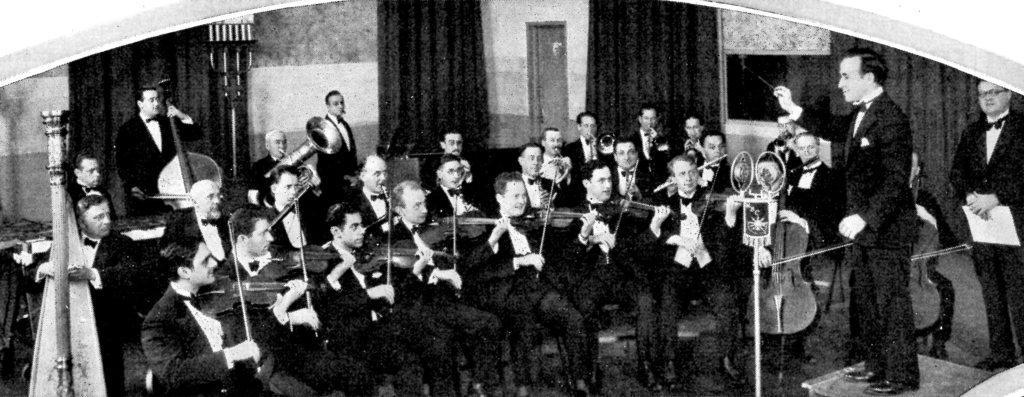Could you give a brief overview of what you see in this image? In the picture we can see a group of people sitting on the chairs and playing the musical instruments and they are in blazers, ties and shirts and in front of them we can see a man giving training to them and behind them we can see few people are standing with musical instruments and in the background we can see a wall with some curtains and a door to it. 